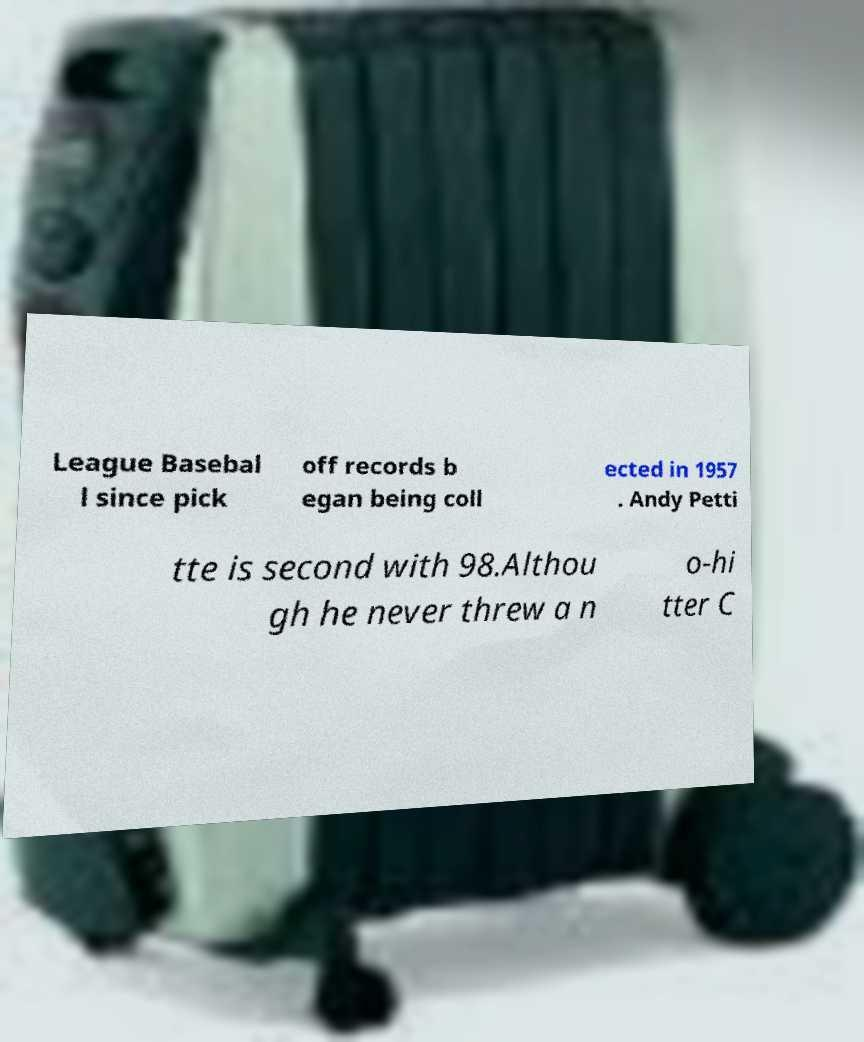Please identify and transcribe the text found in this image. League Basebal l since pick off records b egan being coll ected in 1957 . Andy Petti tte is second with 98.Althou gh he never threw a n o-hi tter C 